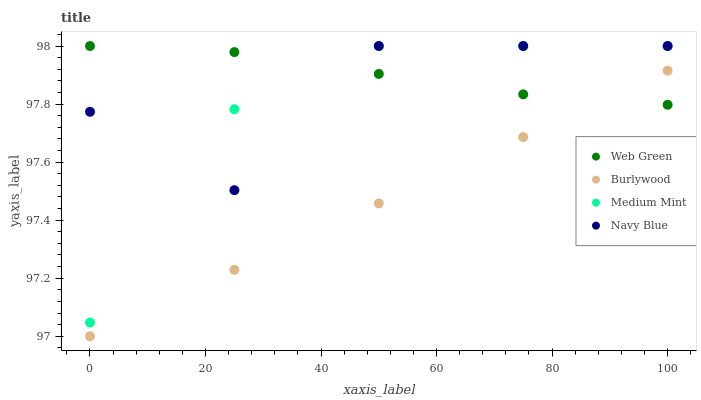Does Burlywood have the minimum area under the curve?
Answer yes or no. Yes. Does Web Green have the maximum area under the curve?
Answer yes or no. Yes. Does Medium Mint have the minimum area under the curve?
Answer yes or no. No. Does Medium Mint have the maximum area under the curve?
Answer yes or no. No. Is Burlywood the smoothest?
Answer yes or no. Yes. Is Navy Blue the roughest?
Answer yes or no. Yes. Is Medium Mint the smoothest?
Answer yes or no. No. Is Medium Mint the roughest?
Answer yes or no. No. Does Burlywood have the lowest value?
Answer yes or no. Yes. Does Medium Mint have the lowest value?
Answer yes or no. No. Does Navy Blue have the highest value?
Answer yes or no. Yes. Is Burlywood less than Navy Blue?
Answer yes or no. Yes. Is Navy Blue greater than Burlywood?
Answer yes or no. Yes. Does Navy Blue intersect Web Green?
Answer yes or no. Yes. Is Navy Blue less than Web Green?
Answer yes or no. No. Is Navy Blue greater than Web Green?
Answer yes or no. No. Does Burlywood intersect Navy Blue?
Answer yes or no. No. 